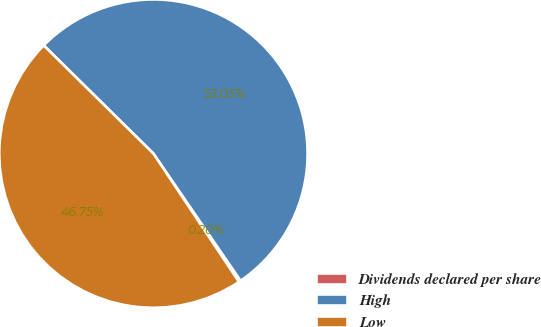Convert chart to OTSL. <chart><loc_0><loc_0><loc_500><loc_500><pie_chart><fcel>Dividends declared per share<fcel>High<fcel>Low<nl><fcel>0.2%<fcel>53.05%<fcel>46.75%<nl></chart> 